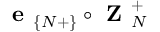<formula> <loc_0><loc_0><loc_500><loc_500>e _ { \{ N + \} } \circ Z _ { N } ^ { + }</formula> 